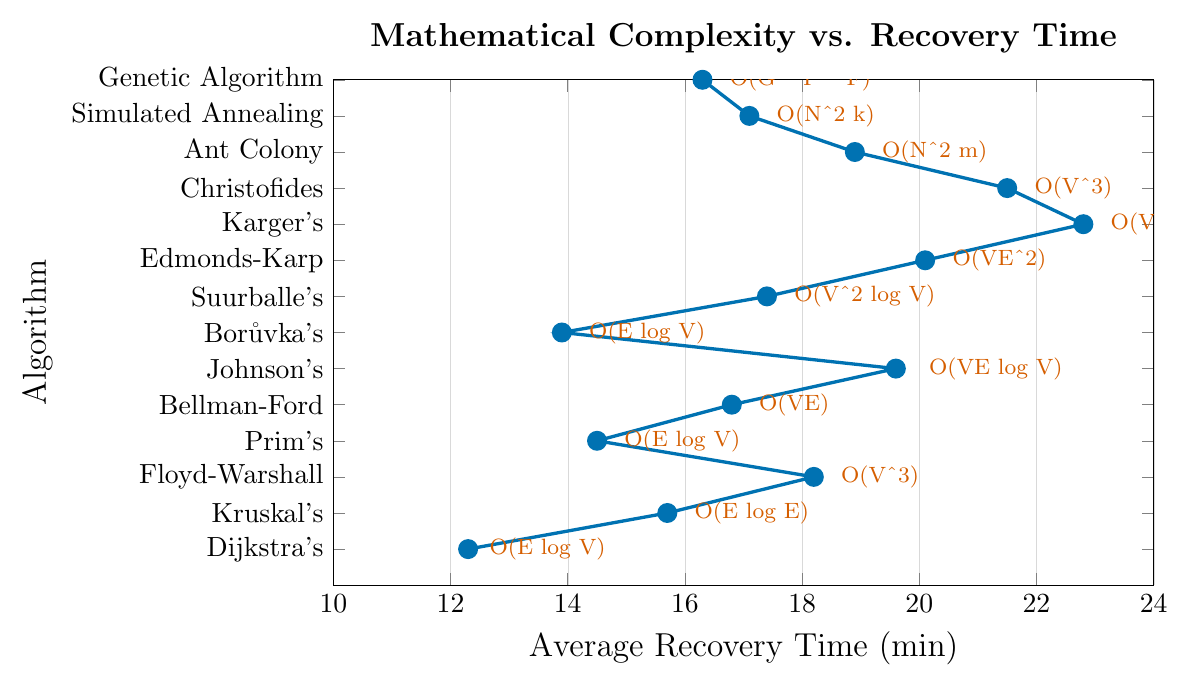What is the average recovery time for the algorithms? To find the average recovery time, add up all the recovery times and then divide by the number of algorithms. The sum of recovery times is 12.3 + 15.7 + 18.2 + 14.5 + 16.8 + 19.6 + 13.9 + 17.4 + 20.1 + 22.8 + 21.5 + 18.9 + 17.1 + 16.3 = 245.1 minutes. There are 14 algorithms, so the average is 245.1 / 14 = 17.507 minutes.
Answer: 17.507 minutes Which algorithm has the shortest average recovery time? Look at the y-axis labels to find the algorithm with the smallest x-axis value. Dijkstra's Shortest Path has the shortest average recovery time of 12.3 minutes.
Answer: Dijkstra's Shortest Path What is the range of the average recovery times? The range is found by subtracting the smallest recovery time from the largest. The smallest recovery time is 12.3 (Dijkstra's Shortest Path), and the largest is 22.8 (Karger's Minimum Cut). So, the range is 22.8 - 12.3 = 10.5 minutes.
Answer: 10.5 minutes Which algorithm takes more average recovery time: Prim's Minimum Spanning Tree or Bellman-Ford Shortest Path? Refer to the x-axis values for both algorithms. Prim's has an average recovery time of 14.5 minutes, while Bellman-Ford has 16.8 minutes. Thus, Bellman-Ford takes more time.
Answer: Bellman-Ford Shortest Path What is the difference in recovery time between the algorithm with the highest complexity and the one with the lowest complexity? The highest complexity is O(V^4) (Karger's Minimum Cut) with a recovery time of 22.8 minutes. The lowest complexity is O(E log V) (Dijkstra's Shortest Path) with a recovery time of 12.3 minutes. The difference is 22.8 - 12.3 = 10.5 minutes.
Answer: 10.5 minutes How many algorithms have a recovery time greater than 18 minutes? Count the number of algorithms with x-axis values greater than 18. They are Floyd-Warshall (18.2), Johnson's (19.6), Edmonds-Karp (20.1), Karger's (22.8), Christofides (21.5), Ant Colony (18.9). So, there are 6 such algorithms.
Answer: 6 algorithms Which algorithm with a complexity of O(V^3) has a shorter recovery time? Floyd-Warshall or Christofides? Check the recovery times for both. Floyd-Warshall has a recovery time of 18.2 minutes, and Christofides has 21.5 minutes. Hence, Floyd-Warshall has a shorter recovery time.
Answer: Floyd-Warshall What is the average recovery time of algorithms with complexities related to minimum spanning trees? The algorithms related to minimum spanning trees are Kruskal's (15.7), Prim's (14.5), Borůvka's (13.9). Add their recovery times and divide by the number of algorithms: (15.7 + 14.5 + 13.9) / 3 = 14.7 minutes.
Answer: 14.7 minutes How does the recovery time of genetic algorithms compare to that of simulated annealing? Genetic Algorithm has a recovery time of 16.3 minutes, and Simulated Annealing has a recovery time of 17.1 minutes. Genetic Algorithm has a shorter recovery time.
Answer: Genetic Algorithm What is the median recovery time for all the algorithms? Arrange the recovery times in ascending order: 12.3, 13.9, 14.5, 15.7, 16.3, 16.8, 17.1, 17.4, 18.2, 18.9, 19.6, 20.1, 21.5, 22.8. The median is the average of the 7th and 8th values. (17.1 + 17.4) / 2 = 17.25 minutes.
Answer: 17.25 minutes 